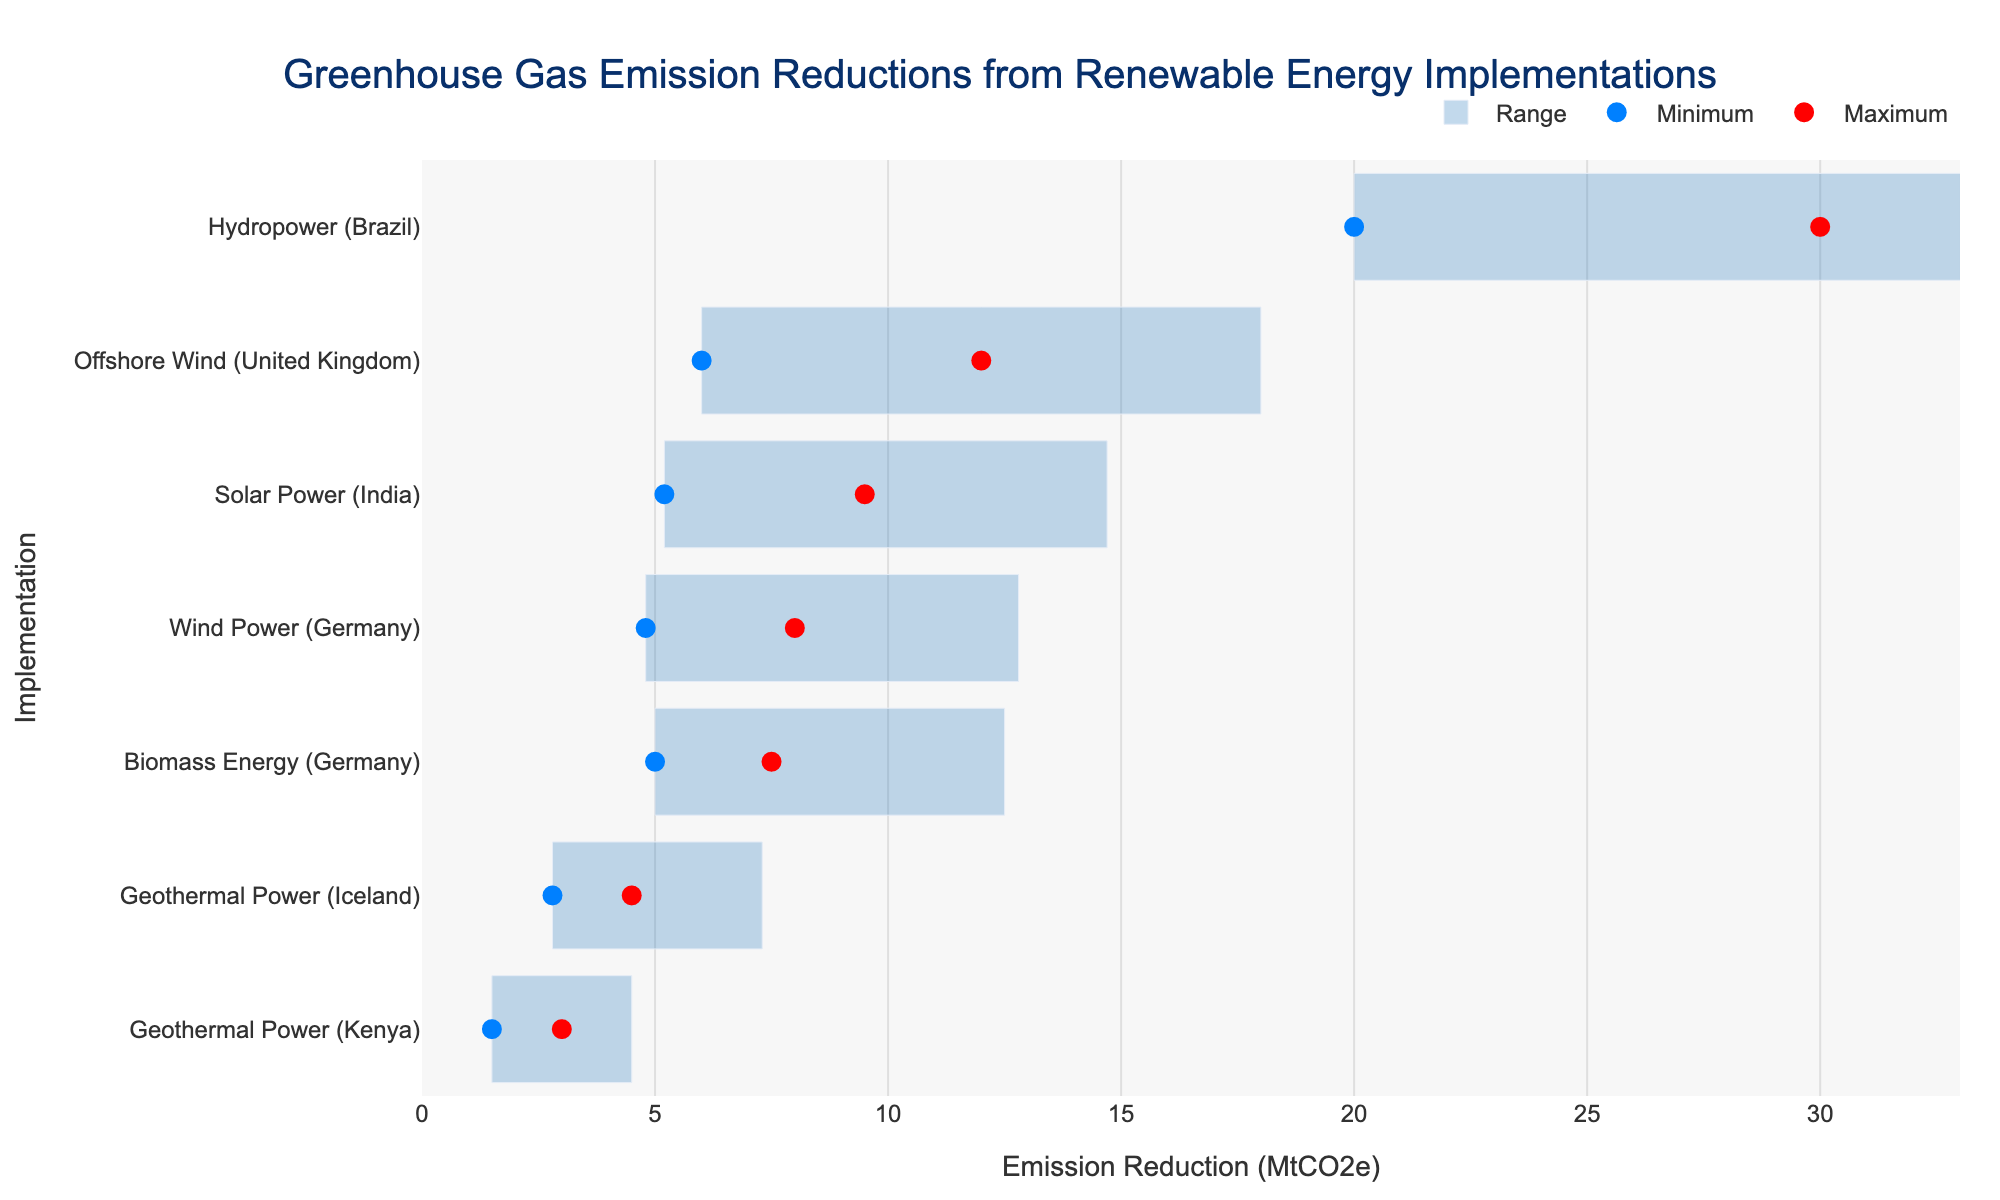Which implementation has the highest maximum reduction in greenhouse gas emissions? Look at the bar representing the highest value on the x-axis and note its corresponding implementation on the y-axis. The highest maximum reduction is found at "30 MtCO2e" for "Hydropower (Brazil)".
Answer: Hydropower (Brazil) What is the range of greenhouse gas emission reductions for Offshore Wind in the United Kingdom? Identify the bar corresponding to "Offshore Wind (United Kingdom)" and check its minimum and maximum points on the x-axis. The minimum reduction is 6.0 MtCO2e, and the maximum is 12.0 MtCO2e, so the range is from 6.0 to 12.0 MtCO2e.
Answer: 6.0 to 12.0 MtCO2e Which implementation has the smallest minimum reduction in greenhouse gas emissions? Locate the points representing the minimum values on the x-axis and find the implementation with the smallest value, which appears at "1.5 MtCO2e" for "Geothermal Power (Kenya)".
Answer: Geothermal Power (Kenya) How many implementations have a maximum reduction of fewer than 10 MtCO2e? Count the number of bars where the maximum value on the x-axis is less than 10 MtCO2e. The implementations are Geothermal Power (Iceland), Biomass Energy (Germany), Solar Power (India), Wind Power (Germany), and Geothermal Power (Kenya). There are five in total.
Answer: 5 Which implementations have an overlap in their range of reductions? Look for bars on the figure where ranges (represented by the bars) cross each other. For instance, Solar Power (India) and Offshore Wind (United Kingdom) both have values from around 6.0 to 9.5 MtCO2e. The overlapping implementations are Solar Power (India) and Offshore Wind (United Kingdom), Biomass Energy (Germany) and Wind Power (Germany).
Answer: Solar Power (India) and Offshore Wind (United Kingdom); Biomass Energy (Germany) and Wind Power (Germany) Which renewable energy implementation has the widest range of emission reductions? Measure the width of each bar, representing the difference between the maximum and minimum reductions. Hydropower (Brazil) spans from 20.0 to 30.0 MtCO2e, covering a range of 10.0 MtCO2e, which is the widest.
Answer: Hydropower (Brazil) What is the difference between maximum and minimum reductions for Biomass Energy in Germany? Identify the bar for Biomass Energy (Germany), noting its maximum (7.5 MtCO2e) and minimum (5.0 MtCO2e) values. Calculate the difference as 7.5 - 5.0 = 2.5 MtCO2e.
Answer: 2.5 MtCO2e Among the listed implementations, which one has reductions entirely contained within the range of Hydropower (Brazil)? Compare each implementation's range with Hydropower (Brazil) (20.0 to 30.0 MtCO2e). None of the implementations have reductions that entirely fall within the 20.0 to 30.0 MtCO2e range of Hydropower (Brazil).
Answer: None 